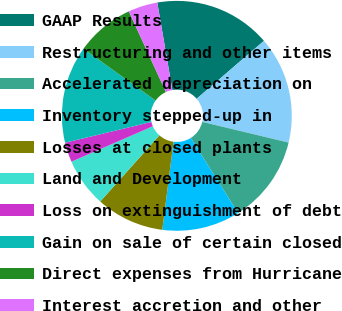Convert chart to OTSL. <chart><loc_0><loc_0><loc_500><loc_500><pie_chart><fcel>GAAP Results<fcel>Restructuring and other items<fcel>Accelerated depreciation on<fcel>Inventory stepped-up in<fcel>Losses at closed plants<fcel>Land and Development<fcel>Loss on extinguishment of debt<fcel>Gain on sale of certain closed<fcel>Direct expenses from Hurricane<fcel>Interest accretion and other<nl><fcel>16.41%<fcel>15.05%<fcel>12.32%<fcel>10.96%<fcel>9.59%<fcel>6.86%<fcel>2.77%<fcel>13.68%<fcel>8.23%<fcel>4.13%<nl></chart> 